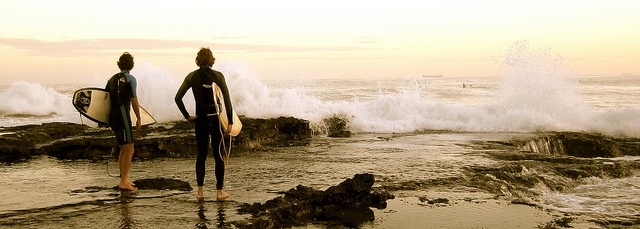Describe the objects in this image and their specific colors. I can see people in ivory, black, olive, and maroon tones, people in ivory, black, maroon, olive, and beige tones, surfboard in ivory, black, olive, and tan tones, and surfboard in ivory, tan, black, and olive tones in this image. 